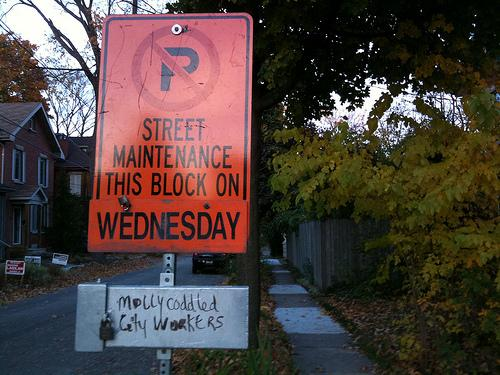What is the primary color of the street sign and what does it say? The primary color of the street sign is orange, and it says "street maintenance." Based on the provided information, in which season might this image have been taken? The image might have been taken during autumn, given the presence of yellow and orange leaves on trees. How many houses are visible in the image and what color are their walls and roofs? Two houses are visible in the image with red walls and red roofs. What can you infer about the environment in which this photo was taken? The environment appears to be a residential area in autumn, with yellow and orange leaves on trees, a grey road, and houses with red walls and white windows. Identify the color and shape of the object described by the phrase "yellow leaves by sidwalk". The object is a group of yellow leaves, found in a square area with dimensions of 228x228. What is the main purpose of the orange street sign in the image? The main purpose of the orange street sign is to inform about street maintenance in the area. Identify a type of vehicle and its color mentioned in the image and provide its dimensions. A black vehicle is mentioned in the image with dimensions of 108x108. How would you describe the message being conveyed by the graffiti found in the image? It is difficult to describe the message conveyed by the handwritten graffiti on the metal sign, as the text within the bounding box is not provided. Describe the overall sentiment or mood conveyed by the image. The image conveys a somewhat tranquil and peaceful mood, with a residential area and colorful autumn leaves. Try to spot the pink butterfly resting on a vibrant purple flower at the top right corner of the image. This instruction is misleading because it talks about a non-existent object (pink butterfly on a purple flower) and uses vivid colors to create an illusion of something that doesn't exist within the image. Did you notice the neon green alien-shaped graffiti written on the wall of the red house? This instruction is misleading because it brings up the visualization of a colorful, odd-shaped graffiti on a house's wall, which doesn't exist in the image. It also encourages the viewer to look for it by asking a question (interrogative sentence). Does the green UFO floating above the trees give you a feeling of an extraterrestrial situation? This instruction is misleading because it introduces a non-existent object (UFO) with an intriguing context, prompting viewers to look for connections between the image and the alleged extraterrestrial situation. It uses an interrogative sentence to make the viewer question their own perceptions. In the lower left part of the image, a family of ducks is swimming happily in a small pond. This instruction is misleading because it presents a false narrative about a group of animals in a non-existent setting (ducks in a pond). It describes the action, making it seem like it's a part of the image even though it's not. The person sitting at the cafe table, wearing sunglasses and holding a cup of coffee adds a touch of realism to the scene. This instruction is misleading because it introduces an entirely new scenario within the image that doesn't exist (a cafe setting). It uses a declarative sentence to establish the presence of a person engaged in an activity, making it seem more believable. Can you see the person wearing a blue hat riding a bicycle in front of the houses? This instruction is misleading because it introduces a human figure that doesn't appear in the image. It also asks a question (interrogative sentence) to engage the reader in searching for the non-existent object (person riding a bicycle). 